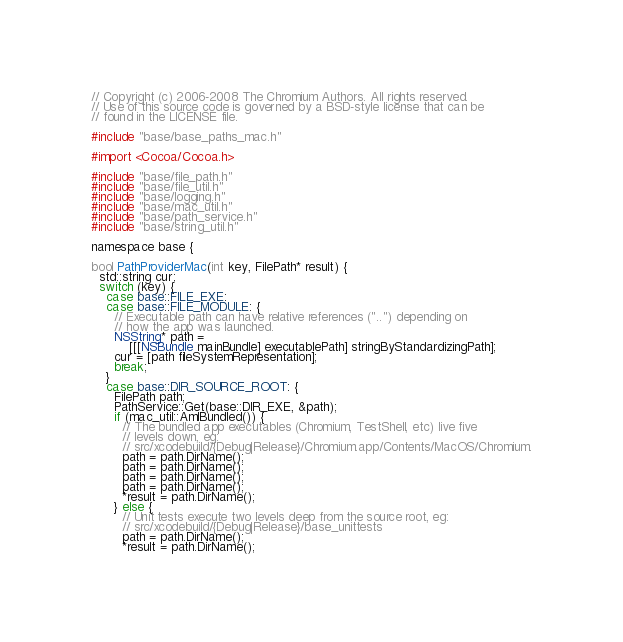<code> <loc_0><loc_0><loc_500><loc_500><_ObjectiveC_>// Copyright (c) 2006-2008 The Chromium Authors. All rights reserved.
// Use of this source code is governed by a BSD-style license that can be
// found in the LICENSE file.

#include "base/base_paths_mac.h"

#import <Cocoa/Cocoa.h>

#include "base/file_path.h"
#include "base/file_util.h"
#include "base/logging.h"
#include "base/mac_util.h"
#include "base/path_service.h"
#include "base/string_util.h"

namespace base {

bool PathProviderMac(int key, FilePath* result) {
  std::string cur;
  switch (key) {
    case base::FILE_EXE:
    case base::FILE_MODULE: {
      // Executable path can have relative references ("..") depending on
      // how the app was launched.
      NSString* path =
          [[[NSBundle mainBundle] executablePath] stringByStandardizingPath];
      cur = [path fileSystemRepresentation];
      break;
    }
    case base::DIR_SOURCE_ROOT: {
      FilePath path;
      PathService::Get(base::DIR_EXE, &path);
      if (mac_util::AmIBundled()) {
        // The bundled app executables (Chromium, TestShell, etc) live five
        // levels down, eg:
        // src/xcodebuild/{Debug|Release}/Chromium.app/Contents/MacOS/Chromium.
        path = path.DirName();
        path = path.DirName();
        path = path.DirName();
        path = path.DirName();
        *result = path.DirName();
      } else {
        // Unit tests execute two levels deep from the source root, eg:
        // src/xcodebuild/{Debug|Release}/base_unittests
        path = path.DirName();
        *result = path.DirName();</code> 